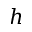<formula> <loc_0><loc_0><loc_500><loc_500>h</formula> 